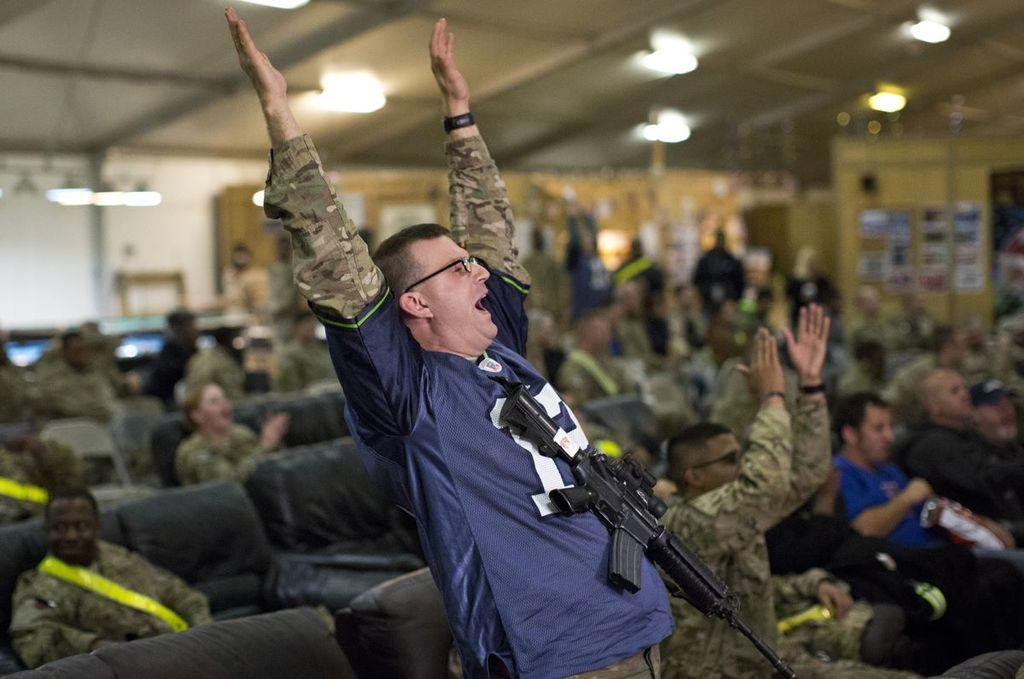How many people are in the image? There are people in the image, but the exact number is not specified. What is the man carrying in the image? The man is carrying a bag in the image. What type of furniture is present in the image? There are couches in the image. What can be observed about the background of the image? The background of the image is blurry, and there are lights and objects visible. What type of pickle is the person holding in the image? There is no person holding a pickle in the image; the man is carrying a bag. 